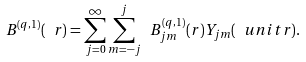<formula> <loc_0><loc_0><loc_500><loc_500>B ^ { ( q , 1 ) } ( \ r ) = \sum _ { j = 0 } ^ { \infty } \sum _ { m = - j } ^ { j } \ B ^ { ( q , 1 ) } _ { j m } ( r ) Y _ { j m } ( \ u n i t r ) .</formula> 